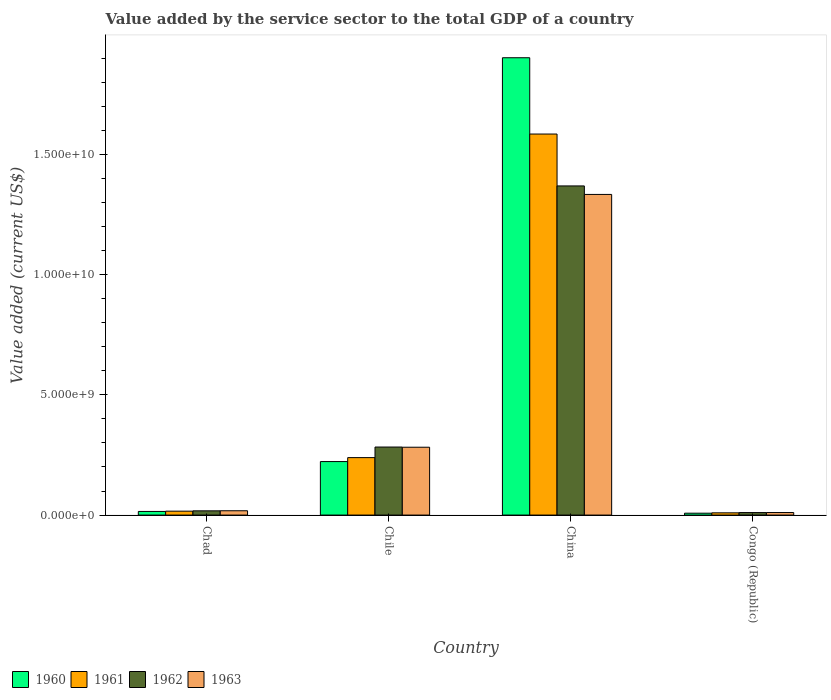How many different coloured bars are there?
Give a very brief answer. 4. How many groups of bars are there?
Give a very brief answer. 4. Are the number of bars per tick equal to the number of legend labels?
Make the answer very short. Yes. What is the label of the 2nd group of bars from the left?
Offer a very short reply. Chile. In how many cases, is the number of bars for a given country not equal to the number of legend labels?
Offer a very short reply. 0. What is the value added by the service sector to the total GDP in 1961 in Chile?
Provide a succinct answer. 2.39e+09. Across all countries, what is the maximum value added by the service sector to the total GDP in 1961?
Your response must be concise. 1.58e+1. Across all countries, what is the minimum value added by the service sector to the total GDP in 1961?
Offer a terse response. 9.33e+07. In which country was the value added by the service sector to the total GDP in 1961 minimum?
Make the answer very short. Congo (Republic). What is the total value added by the service sector to the total GDP in 1963 in the graph?
Give a very brief answer. 1.64e+1. What is the difference between the value added by the service sector to the total GDP in 1962 in Chile and that in Congo (Republic)?
Your answer should be very brief. 2.73e+09. What is the difference between the value added by the service sector to the total GDP in 1960 in China and the value added by the service sector to the total GDP in 1963 in Chile?
Ensure brevity in your answer.  1.62e+1. What is the average value added by the service sector to the total GDP in 1960 per country?
Your answer should be very brief. 5.37e+09. What is the difference between the value added by the service sector to the total GDP of/in 1960 and value added by the service sector to the total GDP of/in 1962 in Congo (Republic)?
Provide a short and direct response. -2.55e+07. What is the ratio of the value added by the service sector to the total GDP in 1960 in Chad to that in Congo (Republic)?
Your answer should be very brief. 1.93. Is the value added by the service sector to the total GDP in 1962 in Chile less than that in China?
Keep it short and to the point. Yes. What is the difference between the highest and the second highest value added by the service sector to the total GDP in 1960?
Provide a short and direct response. -1.89e+1. What is the difference between the highest and the lowest value added by the service sector to the total GDP in 1961?
Your answer should be compact. 1.57e+1. In how many countries, is the value added by the service sector to the total GDP in 1962 greater than the average value added by the service sector to the total GDP in 1962 taken over all countries?
Offer a very short reply. 1. Is the sum of the value added by the service sector to the total GDP in 1963 in Chad and Chile greater than the maximum value added by the service sector to the total GDP in 1962 across all countries?
Provide a succinct answer. No. Is it the case that in every country, the sum of the value added by the service sector to the total GDP in 1962 and value added by the service sector to the total GDP in 1960 is greater than the sum of value added by the service sector to the total GDP in 1963 and value added by the service sector to the total GDP in 1961?
Offer a very short reply. No. What does the 2nd bar from the left in Chile represents?
Make the answer very short. 1961. Are all the bars in the graph horizontal?
Make the answer very short. No. How many countries are there in the graph?
Keep it short and to the point. 4. What is the difference between two consecutive major ticks on the Y-axis?
Offer a terse response. 5.00e+09. Where does the legend appear in the graph?
Offer a very short reply. Bottom left. How many legend labels are there?
Your answer should be compact. 4. What is the title of the graph?
Offer a terse response. Value added by the service sector to the total GDP of a country. What is the label or title of the Y-axis?
Offer a terse response. Value added (current US$). What is the Value added (current US$) in 1960 in Chad?
Make the answer very short. 1.51e+08. What is the Value added (current US$) of 1961 in Chad?
Offer a terse response. 1.62e+08. What is the Value added (current US$) in 1962 in Chad?
Your answer should be very brief. 1.76e+08. What is the Value added (current US$) of 1963 in Chad?
Give a very brief answer. 1.80e+08. What is the Value added (current US$) in 1960 in Chile?
Offer a terse response. 2.22e+09. What is the Value added (current US$) in 1961 in Chile?
Your answer should be compact. 2.39e+09. What is the Value added (current US$) of 1962 in Chile?
Keep it short and to the point. 2.83e+09. What is the Value added (current US$) of 1963 in Chile?
Provide a succinct answer. 2.82e+09. What is the Value added (current US$) in 1960 in China?
Provide a succinct answer. 1.90e+1. What is the Value added (current US$) of 1961 in China?
Offer a terse response. 1.58e+1. What is the Value added (current US$) of 1962 in China?
Your response must be concise. 1.37e+1. What is the Value added (current US$) in 1963 in China?
Make the answer very short. 1.33e+1. What is the Value added (current US$) of 1960 in Congo (Republic)?
Make the answer very short. 7.82e+07. What is the Value added (current US$) of 1961 in Congo (Republic)?
Offer a terse response. 9.33e+07. What is the Value added (current US$) of 1962 in Congo (Republic)?
Ensure brevity in your answer.  1.04e+08. What is the Value added (current US$) in 1963 in Congo (Republic)?
Offer a terse response. 1.06e+08. Across all countries, what is the maximum Value added (current US$) of 1960?
Give a very brief answer. 1.90e+1. Across all countries, what is the maximum Value added (current US$) in 1961?
Give a very brief answer. 1.58e+1. Across all countries, what is the maximum Value added (current US$) of 1962?
Your response must be concise. 1.37e+1. Across all countries, what is the maximum Value added (current US$) in 1963?
Your answer should be compact. 1.33e+1. Across all countries, what is the minimum Value added (current US$) in 1960?
Keep it short and to the point. 7.82e+07. Across all countries, what is the minimum Value added (current US$) of 1961?
Make the answer very short. 9.33e+07. Across all countries, what is the minimum Value added (current US$) of 1962?
Offer a terse response. 1.04e+08. Across all countries, what is the minimum Value added (current US$) in 1963?
Your answer should be compact. 1.06e+08. What is the total Value added (current US$) of 1960 in the graph?
Your answer should be very brief. 2.15e+1. What is the total Value added (current US$) in 1961 in the graph?
Provide a succinct answer. 1.85e+1. What is the total Value added (current US$) of 1962 in the graph?
Give a very brief answer. 1.68e+1. What is the total Value added (current US$) of 1963 in the graph?
Your answer should be compact. 1.64e+1. What is the difference between the Value added (current US$) of 1960 in Chad and that in Chile?
Ensure brevity in your answer.  -2.07e+09. What is the difference between the Value added (current US$) in 1961 in Chad and that in Chile?
Make the answer very short. -2.23e+09. What is the difference between the Value added (current US$) in 1962 in Chad and that in Chile?
Ensure brevity in your answer.  -2.65e+09. What is the difference between the Value added (current US$) in 1963 in Chad and that in Chile?
Offer a terse response. -2.64e+09. What is the difference between the Value added (current US$) in 1960 in Chad and that in China?
Offer a very short reply. -1.89e+1. What is the difference between the Value added (current US$) of 1961 in Chad and that in China?
Keep it short and to the point. -1.57e+1. What is the difference between the Value added (current US$) of 1962 in Chad and that in China?
Ensure brevity in your answer.  -1.35e+1. What is the difference between the Value added (current US$) in 1963 in Chad and that in China?
Give a very brief answer. -1.32e+1. What is the difference between the Value added (current US$) of 1960 in Chad and that in Congo (Republic)?
Make the answer very short. 7.27e+07. What is the difference between the Value added (current US$) of 1961 in Chad and that in Congo (Republic)?
Provide a succinct answer. 6.92e+07. What is the difference between the Value added (current US$) in 1962 in Chad and that in Congo (Republic)?
Your answer should be very brief. 7.25e+07. What is the difference between the Value added (current US$) in 1963 in Chad and that in Congo (Republic)?
Provide a short and direct response. 7.41e+07. What is the difference between the Value added (current US$) in 1960 in Chile and that in China?
Ensure brevity in your answer.  -1.68e+1. What is the difference between the Value added (current US$) in 1961 in Chile and that in China?
Offer a terse response. -1.35e+1. What is the difference between the Value added (current US$) in 1962 in Chile and that in China?
Your answer should be very brief. -1.09e+1. What is the difference between the Value added (current US$) in 1963 in Chile and that in China?
Keep it short and to the point. -1.05e+1. What is the difference between the Value added (current US$) of 1960 in Chile and that in Congo (Republic)?
Ensure brevity in your answer.  2.15e+09. What is the difference between the Value added (current US$) in 1961 in Chile and that in Congo (Republic)?
Your response must be concise. 2.30e+09. What is the difference between the Value added (current US$) of 1962 in Chile and that in Congo (Republic)?
Offer a very short reply. 2.73e+09. What is the difference between the Value added (current US$) of 1963 in Chile and that in Congo (Republic)?
Give a very brief answer. 2.72e+09. What is the difference between the Value added (current US$) of 1960 in China and that in Congo (Republic)?
Ensure brevity in your answer.  1.89e+1. What is the difference between the Value added (current US$) in 1961 in China and that in Congo (Republic)?
Make the answer very short. 1.57e+1. What is the difference between the Value added (current US$) in 1962 in China and that in Congo (Republic)?
Keep it short and to the point. 1.36e+1. What is the difference between the Value added (current US$) in 1963 in China and that in Congo (Republic)?
Offer a very short reply. 1.32e+1. What is the difference between the Value added (current US$) of 1960 in Chad and the Value added (current US$) of 1961 in Chile?
Provide a succinct answer. -2.24e+09. What is the difference between the Value added (current US$) in 1960 in Chad and the Value added (current US$) in 1962 in Chile?
Ensure brevity in your answer.  -2.68e+09. What is the difference between the Value added (current US$) of 1960 in Chad and the Value added (current US$) of 1963 in Chile?
Offer a very short reply. -2.67e+09. What is the difference between the Value added (current US$) of 1961 in Chad and the Value added (current US$) of 1962 in Chile?
Give a very brief answer. -2.67e+09. What is the difference between the Value added (current US$) of 1961 in Chad and the Value added (current US$) of 1963 in Chile?
Provide a short and direct response. -2.66e+09. What is the difference between the Value added (current US$) in 1962 in Chad and the Value added (current US$) in 1963 in Chile?
Your response must be concise. -2.64e+09. What is the difference between the Value added (current US$) of 1960 in Chad and the Value added (current US$) of 1961 in China?
Make the answer very short. -1.57e+1. What is the difference between the Value added (current US$) of 1960 in Chad and the Value added (current US$) of 1962 in China?
Keep it short and to the point. -1.35e+1. What is the difference between the Value added (current US$) in 1960 in Chad and the Value added (current US$) in 1963 in China?
Keep it short and to the point. -1.32e+1. What is the difference between the Value added (current US$) of 1961 in Chad and the Value added (current US$) of 1962 in China?
Offer a terse response. -1.35e+1. What is the difference between the Value added (current US$) of 1961 in Chad and the Value added (current US$) of 1963 in China?
Offer a terse response. -1.32e+1. What is the difference between the Value added (current US$) of 1962 in Chad and the Value added (current US$) of 1963 in China?
Your response must be concise. -1.32e+1. What is the difference between the Value added (current US$) of 1960 in Chad and the Value added (current US$) of 1961 in Congo (Republic)?
Your answer should be very brief. 5.77e+07. What is the difference between the Value added (current US$) of 1960 in Chad and the Value added (current US$) of 1962 in Congo (Republic)?
Your answer should be very brief. 4.72e+07. What is the difference between the Value added (current US$) in 1960 in Chad and the Value added (current US$) in 1963 in Congo (Republic)?
Your answer should be very brief. 4.54e+07. What is the difference between the Value added (current US$) of 1961 in Chad and the Value added (current US$) of 1962 in Congo (Republic)?
Keep it short and to the point. 5.87e+07. What is the difference between the Value added (current US$) of 1961 in Chad and the Value added (current US$) of 1963 in Congo (Republic)?
Provide a short and direct response. 5.69e+07. What is the difference between the Value added (current US$) in 1962 in Chad and the Value added (current US$) in 1963 in Congo (Republic)?
Make the answer very short. 7.08e+07. What is the difference between the Value added (current US$) of 1960 in Chile and the Value added (current US$) of 1961 in China?
Keep it short and to the point. -1.36e+1. What is the difference between the Value added (current US$) in 1960 in Chile and the Value added (current US$) in 1962 in China?
Provide a short and direct response. -1.15e+1. What is the difference between the Value added (current US$) of 1960 in Chile and the Value added (current US$) of 1963 in China?
Offer a terse response. -1.11e+1. What is the difference between the Value added (current US$) of 1961 in Chile and the Value added (current US$) of 1962 in China?
Give a very brief answer. -1.13e+1. What is the difference between the Value added (current US$) of 1961 in Chile and the Value added (current US$) of 1963 in China?
Provide a succinct answer. -1.09e+1. What is the difference between the Value added (current US$) of 1962 in Chile and the Value added (current US$) of 1963 in China?
Ensure brevity in your answer.  -1.05e+1. What is the difference between the Value added (current US$) of 1960 in Chile and the Value added (current US$) of 1961 in Congo (Republic)?
Give a very brief answer. 2.13e+09. What is the difference between the Value added (current US$) of 1960 in Chile and the Value added (current US$) of 1962 in Congo (Republic)?
Offer a terse response. 2.12e+09. What is the difference between the Value added (current US$) in 1960 in Chile and the Value added (current US$) in 1963 in Congo (Republic)?
Provide a short and direct response. 2.12e+09. What is the difference between the Value added (current US$) in 1961 in Chile and the Value added (current US$) in 1962 in Congo (Republic)?
Ensure brevity in your answer.  2.29e+09. What is the difference between the Value added (current US$) of 1961 in Chile and the Value added (current US$) of 1963 in Congo (Republic)?
Offer a terse response. 2.28e+09. What is the difference between the Value added (current US$) of 1962 in Chile and the Value added (current US$) of 1963 in Congo (Republic)?
Ensure brevity in your answer.  2.72e+09. What is the difference between the Value added (current US$) of 1960 in China and the Value added (current US$) of 1961 in Congo (Republic)?
Give a very brief answer. 1.89e+1. What is the difference between the Value added (current US$) of 1960 in China and the Value added (current US$) of 1962 in Congo (Republic)?
Offer a terse response. 1.89e+1. What is the difference between the Value added (current US$) in 1960 in China and the Value added (current US$) in 1963 in Congo (Republic)?
Offer a very short reply. 1.89e+1. What is the difference between the Value added (current US$) of 1961 in China and the Value added (current US$) of 1962 in Congo (Republic)?
Your answer should be very brief. 1.57e+1. What is the difference between the Value added (current US$) in 1961 in China and the Value added (current US$) in 1963 in Congo (Republic)?
Your answer should be very brief. 1.57e+1. What is the difference between the Value added (current US$) of 1962 in China and the Value added (current US$) of 1963 in Congo (Republic)?
Make the answer very short. 1.36e+1. What is the average Value added (current US$) in 1960 per country?
Give a very brief answer. 5.37e+09. What is the average Value added (current US$) in 1961 per country?
Provide a short and direct response. 4.62e+09. What is the average Value added (current US$) of 1962 per country?
Provide a short and direct response. 4.20e+09. What is the average Value added (current US$) in 1963 per country?
Ensure brevity in your answer.  4.11e+09. What is the difference between the Value added (current US$) of 1960 and Value added (current US$) of 1961 in Chad?
Ensure brevity in your answer.  -1.15e+07. What is the difference between the Value added (current US$) of 1960 and Value added (current US$) of 1962 in Chad?
Make the answer very short. -2.53e+07. What is the difference between the Value added (current US$) of 1960 and Value added (current US$) of 1963 in Chad?
Give a very brief answer. -2.87e+07. What is the difference between the Value added (current US$) of 1961 and Value added (current US$) of 1962 in Chad?
Make the answer very short. -1.38e+07. What is the difference between the Value added (current US$) of 1961 and Value added (current US$) of 1963 in Chad?
Give a very brief answer. -1.71e+07. What is the difference between the Value added (current US$) of 1962 and Value added (current US$) of 1963 in Chad?
Ensure brevity in your answer.  -3.34e+06. What is the difference between the Value added (current US$) of 1960 and Value added (current US$) of 1961 in Chile?
Give a very brief answer. -1.64e+08. What is the difference between the Value added (current US$) in 1960 and Value added (current US$) in 1962 in Chile?
Provide a short and direct response. -6.04e+08. What is the difference between the Value added (current US$) of 1960 and Value added (current US$) of 1963 in Chile?
Your response must be concise. -5.96e+08. What is the difference between the Value added (current US$) in 1961 and Value added (current US$) in 1962 in Chile?
Your answer should be compact. -4.40e+08. What is the difference between the Value added (current US$) in 1961 and Value added (current US$) in 1963 in Chile?
Make the answer very short. -4.32e+08. What is the difference between the Value added (current US$) of 1962 and Value added (current US$) of 1963 in Chile?
Your response must be concise. 8.01e+06. What is the difference between the Value added (current US$) in 1960 and Value added (current US$) in 1961 in China?
Offer a terse response. 3.17e+09. What is the difference between the Value added (current US$) of 1960 and Value added (current US$) of 1962 in China?
Provide a short and direct response. 5.33e+09. What is the difference between the Value added (current US$) of 1960 and Value added (current US$) of 1963 in China?
Keep it short and to the point. 5.68e+09. What is the difference between the Value added (current US$) of 1961 and Value added (current US$) of 1962 in China?
Keep it short and to the point. 2.16e+09. What is the difference between the Value added (current US$) in 1961 and Value added (current US$) in 1963 in China?
Your response must be concise. 2.51e+09. What is the difference between the Value added (current US$) of 1962 and Value added (current US$) of 1963 in China?
Ensure brevity in your answer.  3.53e+08. What is the difference between the Value added (current US$) in 1960 and Value added (current US$) in 1961 in Congo (Republic)?
Your answer should be very brief. -1.51e+07. What is the difference between the Value added (current US$) in 1960 and Value added (current US$) in 1962 in Congo (Republic)?
Provide a short and direct response. -2.55e+07. What is the difference between the Value added (current US$) of 1960 and Value added (current US$) of 1963 in Congo (Republic)?
Offer a very short reply. -2.73e+07. What is the difference between the Value added (current US$) of 1961 and Value added (current US$) of 1962 in Congo (Republic)?
Your response must be concise. -1.05e+07. What is the difference between the Value added (current US$) in 1961 and Value added (current US$) in 1963 in Congo (Republic)?
Provide a succinct answer. -1.23e+07. What is the difference between the Value added (current US$) of 1962 and Value added (current US$) of 1963 in Congo (Republic)?
Offer a terse response. -1.79e+06. What is the ratio of the Value added (current US$) in 1960 in Chad to that in Chile?
Provide a succinct answer. 0.07. What is the ratio of the Value added (current US$) of 1961 in Chad to that in Chile?
Ensure brevity in your answer.  0.07. What is the ratio of the Value added (current US$) of 1962 in Chad to that in Chile?
Offer a very short reply. 0.06. What is the ratio of the Value added (current US$) in 1963 in Chad to that in Chile?
Your response must be concise. 0.06. What is the ratio of the Value added (current US$) in 1960 in Chad to that in China?
Provide a short and direct response. 0.01. What is the ratio of the Value added (current US$) in 1961 in Chad to that in China?
Give a very brief answer. 0.01. What is the ratio of the Value added (current US$) of 1962 in Chad to that in China?
Keep it short and to the point. 0.01. What is the ratio of the Value added (current US$) of 1963 in Chad to that in China?
Make the answer very short. 0.01. What is the ratio of the Value added (current US$) of 1960 in Chad to that in Congo (Republic)?
Your response must be concise. 1.93. What is the ratio of the Value added (current US$) in 1961 in Chad to that in Congo (Republic)?
Your response must be concise. 1.74. What is the ratio of the Value added (current US$) of 1962 in Chad to that in Congo (Republic)?
Provide a succinct answer. 1.7. What is the ratio of the Value added (current US$) of 1963 in Chad to that in Congo (Republic)?
Offer a terse response. 1.7. What is the ratio of the Value added (current US$) in 1960 in Chile to that in China?
Provide a succinct answer. 0.12. What is the ratio of the Value added (current US$) of 1961 in Chile to that in China?
Provide a short and direct response. 0.15. What is the ratio of the Value added (current US$) in 1962 in Chile to that in China?
Your response must be concise. 0.21. What is the ratio of the Value added (current US$) of 1963 in Chile to that in China?
Provide a succinct answer. 0.21. What is the ratio of the Value added (current US$) in 1960 in Chile to that in Congo (Republic)?
Your answer should be very brief. 28.44. What is the ratio of the Value added (current US$) in 1961 in Chile to that in Congo (Republic)?
Make the answer very short. 25.61. What is the ratio of the Value added (current US$) in 1962 in Chile to that in Congo (Republic)?
Give a very brief answer. 27.27. What is the ratio of the Value added (current US$) of 1963 in Chile to that in Congo (Republic)?
Ensure brevity in your answer.  26.73. What is the ratio of the Value added (current US$) in 1960 in China to that in Congo (Republic)?
Your answer should be very brief. 243.12. What is the ratio of the Value added (current US$) of 1961 in China to that in Congo (Republic)?
Provide a succinct answer. 169.84. What is the ratio of the Value added (current US$) in 1962 in China to that in Congo (Republic)?
Provide a succinct answer. 131.91. What is the ratio of the Value added (current US$) of 1963 in China to that in Congo (Republic)?
Provide a succinct answer. 126.33. What is the difference between the highest and the second highest Value added (current US$) of 1960?
Your answer should be compact. 1.68e+1. What is the difference between the highest and the second highest Value added (current US$) in 1961?
Your answer should be very brief. 1.35e+1. What is the difference between the highest and the second highest Value added (current US$) of 1962?
Offer a terse response. 1.09e+1. What is the difference between the highest and the second highest Value added (current US$) of 1963?
Ensure brevity in your answer.  1.05e+1. What is the difference between the highest and the lowest Value added (current US$) of 1960?
Offer a terse response. 1.89e+1. What is the difference between the highest and the lowest Value added (current US$) in 1961?
Your answer should be compact. 1.57e+1. What is the difference between the highest and the lowest Value added (current US$) of 1962?
Give a very brief answer. 1.36e+1. What is the difference between the highest and the lowest Value added (current US$) of 1963?
Offer a very short reply. 1.32e+1. 